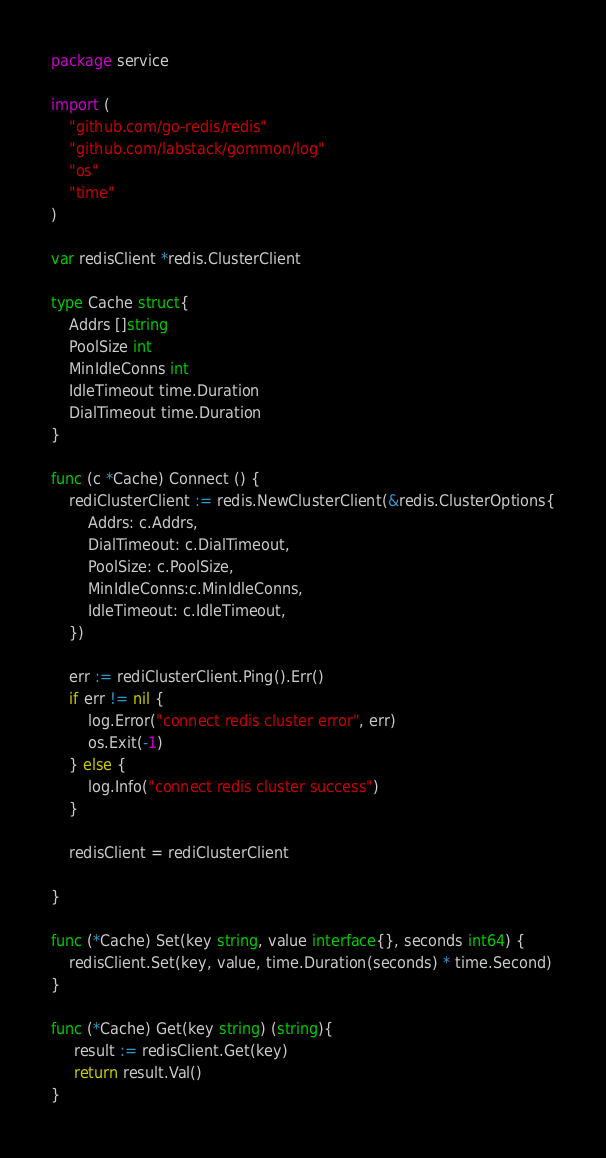<code> <loc_0><loc_0><loc_500><loc_500><_Go_>package service

import (
	"github.com/go-redis/redis"
	"github.com/labstack/gommon/log"
	"os"
	"time"
)

var redisClient *redis.ClusterClient

type Cache struct{
	Addrs []string
	PoolSize int
	MinIdleConns int
	IdleTimeout time.Duration
	DialTimeout time.Duration
}

func (c *Cache) Connect () {
	rediClusterClient := redis.NewClusterClient(&redis.ClusterOptions{
		Addrs: c.Addrs,
		DialTimeout: c.DialTimeout,
		PoolSize: c.PoolSize,
		MinIdleConns:c.MinIdleConns,
		IdleTimeout: c.IdleTimeout,
	})

	err := rediClusterClient.Ping().Err()
	if err != nil {
		log.Error("connect redis cluster error", err)
		os.Exit(-1)
	} else {
		log.Info("connect redis cluster success")
	}

	redisClient = rediClusterClient

}

func (*Cache) Set(key string, value interface{}, seconds int64) {
	redisClient.Set(key, value, time.Duration(seconds) * time.Second)
}

func (*Cache) Get(key string) (string){
	 result := redisClient.Get(key)
	 return result.Val()
}</code> 